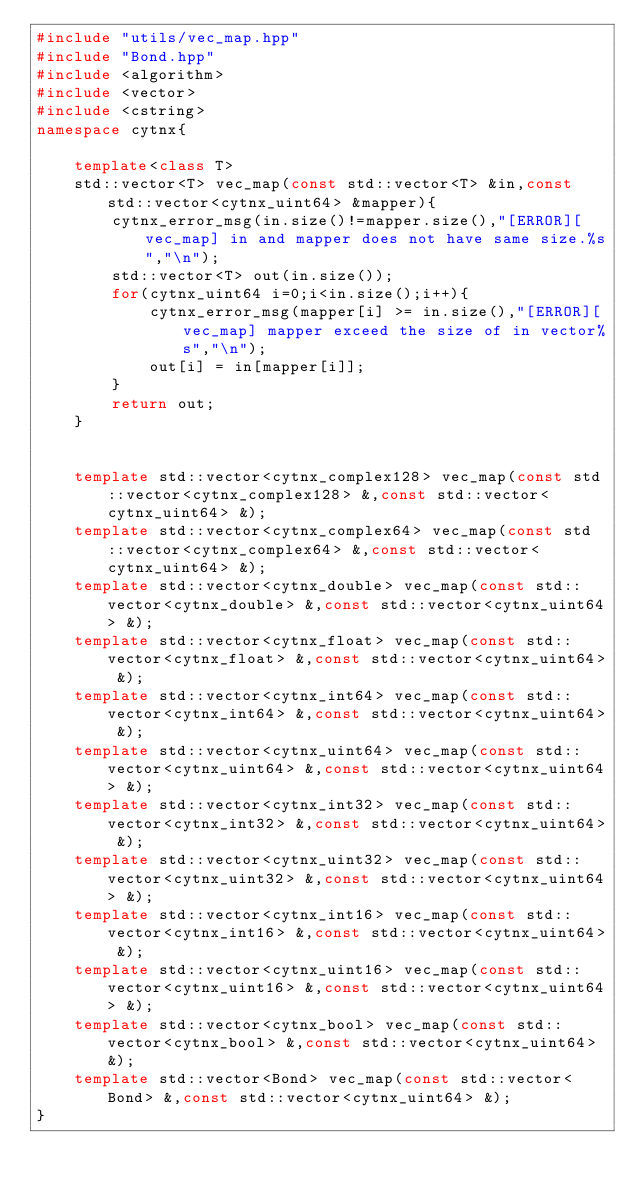Convert code to text. <code><loc_0><loc_0><loc_500><loc_500><_C++_>#include "utils/vec_map.hpp"
#include "Bond.hpp"
#include <algorithm>
#include <vector>
#include <cstring>
namespace cytnx{

    template<class T>
    std::vector<T> vec_map(const std::vector<T> &in,const std::vector<cytnx_uint64> &mapper){
        cytnx_error_msg(in.size()!=mapper.size(),"[ERROR][vec_map] in and mapper does not have same size.%s","\n");
        std::vector<T> out(in.size());
        for(cytnx_uint64 i=0;i<in.size();i++){
            cytnx_error_msg(mapper[i] >= in.size(),"[ERROR][vec_map] mapper exceed the size of in vector%s","\n");
            out[i] = in[mapper[i]];
        }
        return out;
    }


    template std::vector<cytnx_complex128> vec_map(const std::vector<cytnx_complex128> &,const std::vector<cytnx_uint64> &);
    template std::vector<cytnx_complex64> vec_map(const std::vector<cytnx_complex64> &,const std::vector<cytnx_uint64> &);
    template std::vector<cytnx_double> vec_map(const std::vector<cytnx_double> &,const std::vector<cytnx_uint64> &);
    template std::vector<cytnx_float> vec_map(const std::vector<cytnx_float> &,const std::vector<cytnx_uint64> &);
    template std::vector<cytnx_int64> vec_map(const std::vector<cytnx_int64> &,const std::vector<cytnx_uint64> &);
    template std::vector<cytnx_uint64> vec_map(const std::vector<cytnx_uint64> &,const std::vector<cytnx_uint64> &);
    template std::vector<cytnx_int32> vec_map(const std::vector<cytnx_int32> &,const std::vector<cytnx_uint64> &);
    template std::vector<cytnx_uint32> vec_map(const std::vector<cytnx_uint32> &,const std::vector<cytnx_uint64> &);
    template std::vector<cytnx_int16> vec_map(const std::vector<cytnx_int16> &,const std::vector<cytnx_uint64> &);
    template std::vector<cytnx_uint16> vec_map(const std::vector<cytnx_uint16> &,const std::vector<cytnx_uint64> &);
    template std::vector<cytnx_bool> vec_map(const std::vector<cytnx_bool> &,const std::vector<cytnx_uint64> &);
    template std::vector<Bond> vec_map(const std::vector<Bond> &,const std::vector<cytnx_uint64> &);
}
</code> 